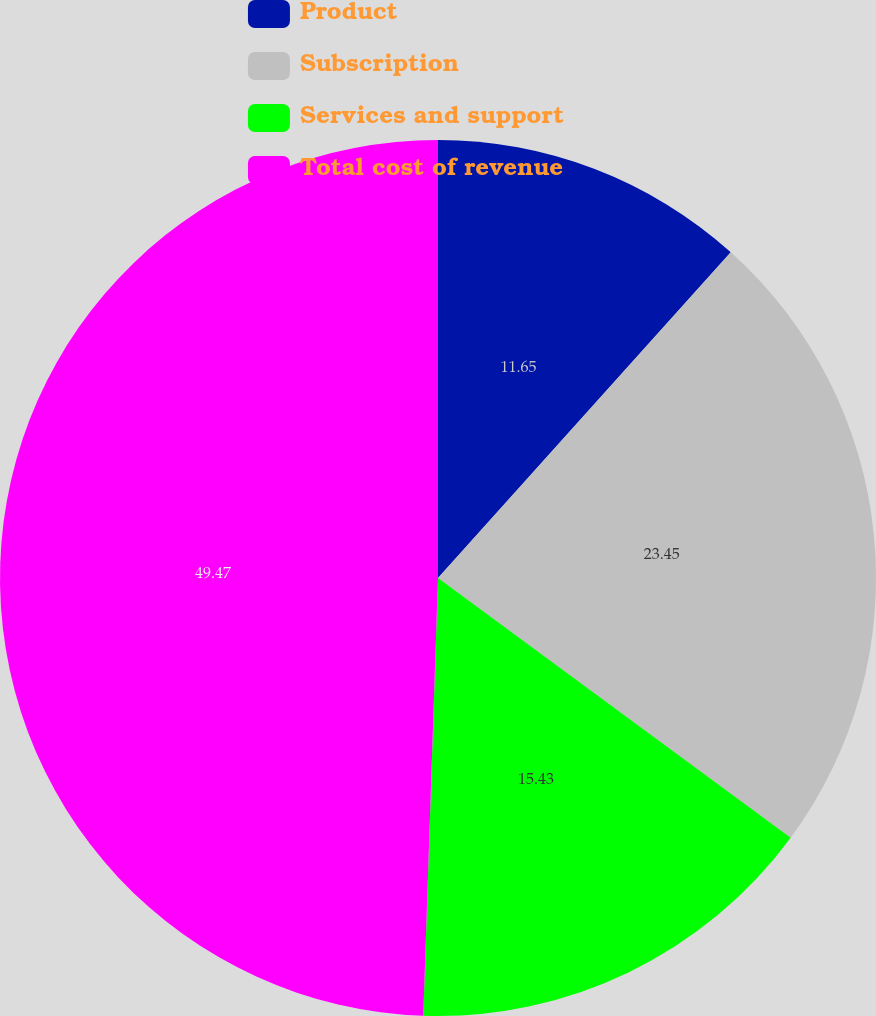<chart> <loc_0><loc_0><loc_500><loc_500><pie_chart><fcel>Product<fcel>Subscription<fcel>Services and support<fcel>Total cost of revenue<nl><fcel>11.65%<fcel>23.45%<fcel>15.43%<fcel>49.46%<nl></chart> 